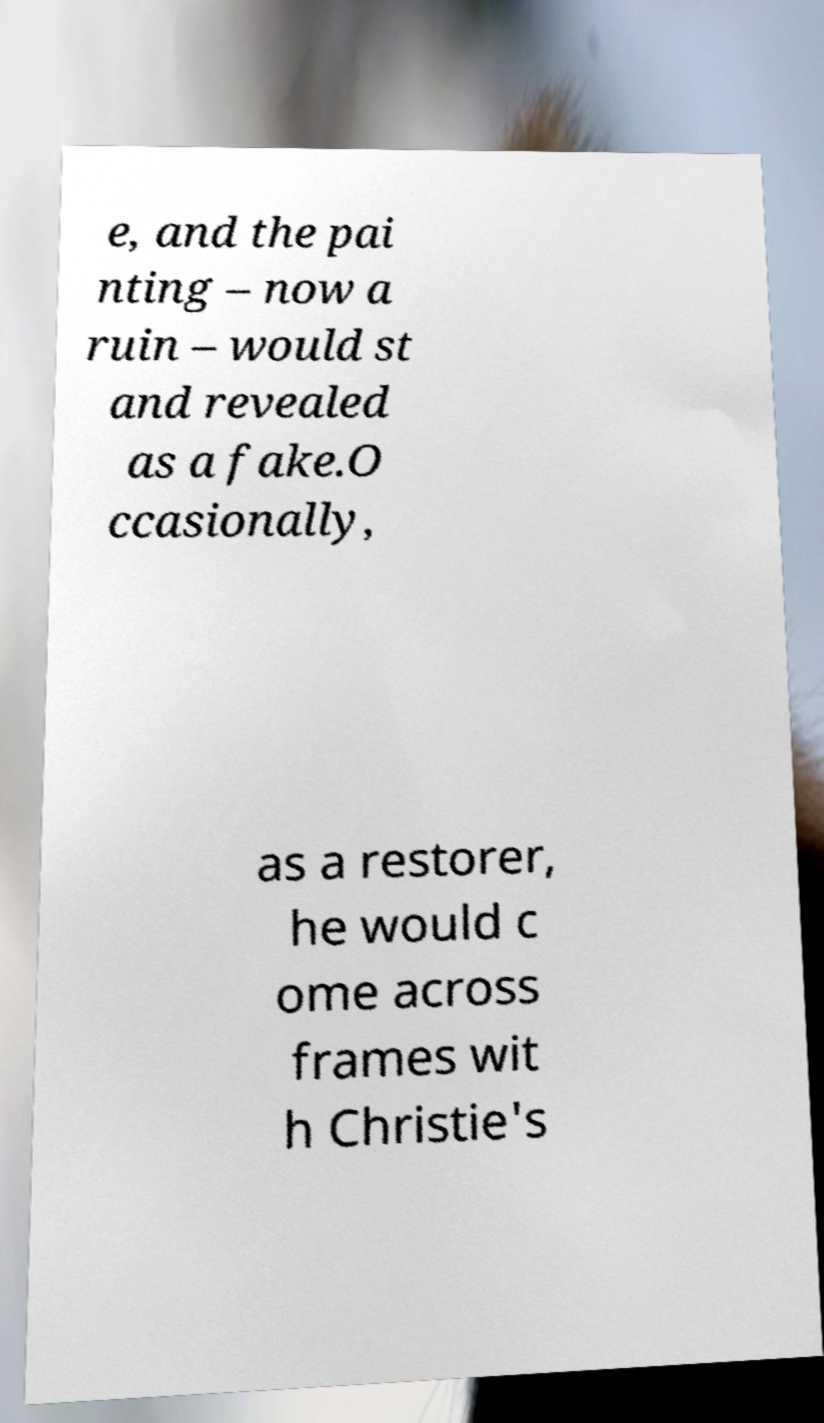There's text embedded in this image that I need extracted. Can you transcribe it verbatim? e, and the pai nting – now a ruin – would st and revealed as a fake.O ccasionally, as a restorer, he would c ome across frames wit h Christie's 